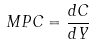<formula> <loc_0><loc_0><loc_500><loc_500>M P C = \frac { d C } { d Y }</formula> 